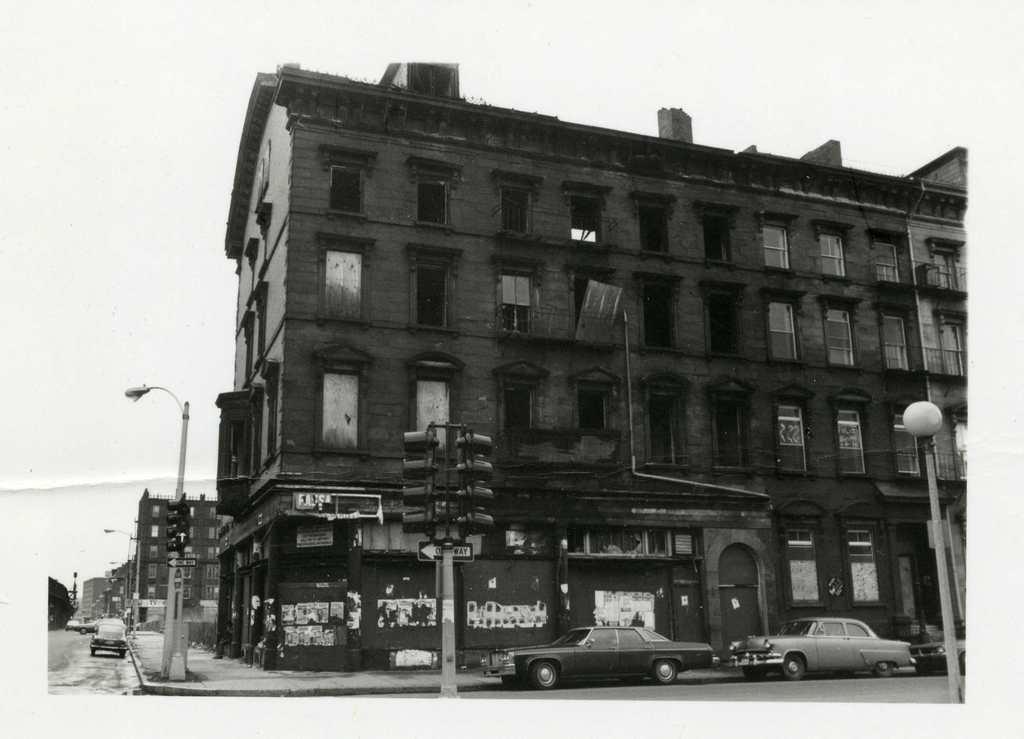Please provide a concise description of this image. In the picture we can see a building with a window and near to it on the path we can see some street lights and on the road we can see some cars and to the building we can see some shops and in the background we can see a sky. 